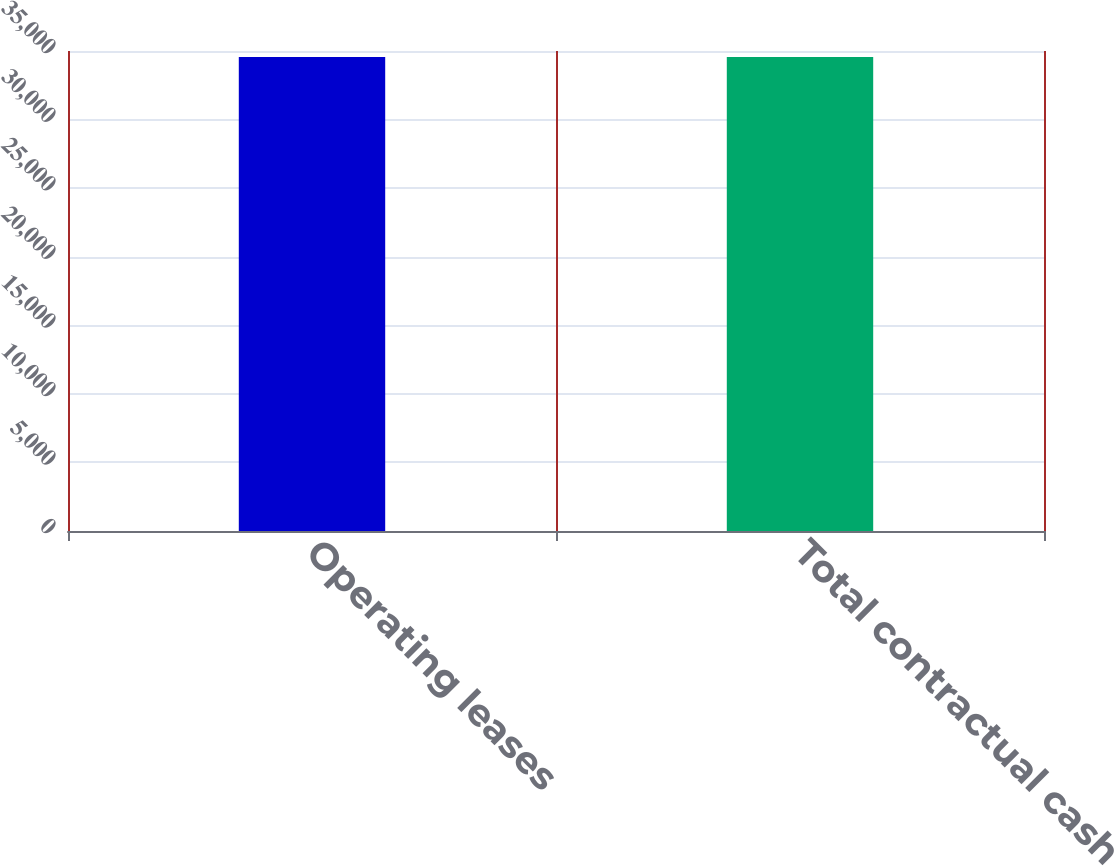Convert chart to OTSL. <chart><loc_0><loc_0><loc_500><loc_500><bar_chart><fcel>Operating leases<fcel>Total contractual cash<nl><fcel>34556<fcel>34556.1<nl></chart> 